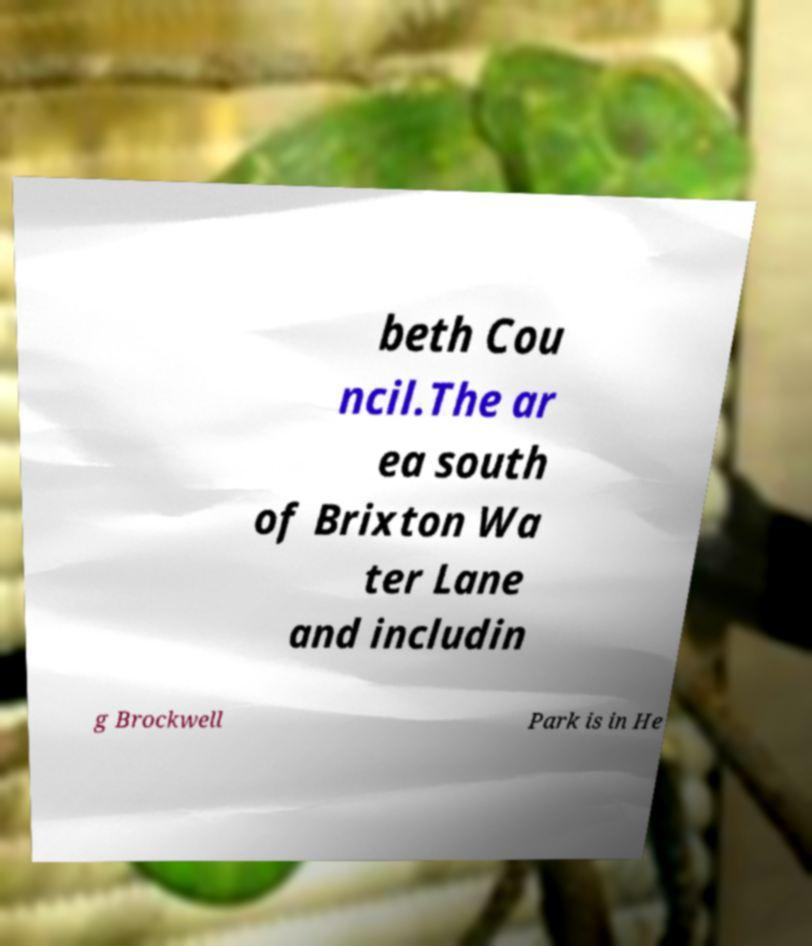Please identify and transcribe the text found in this image. beth Cou ncil.The ar ea south of Brixton Wa ter Lane and includin g Brockwell Park is in He 